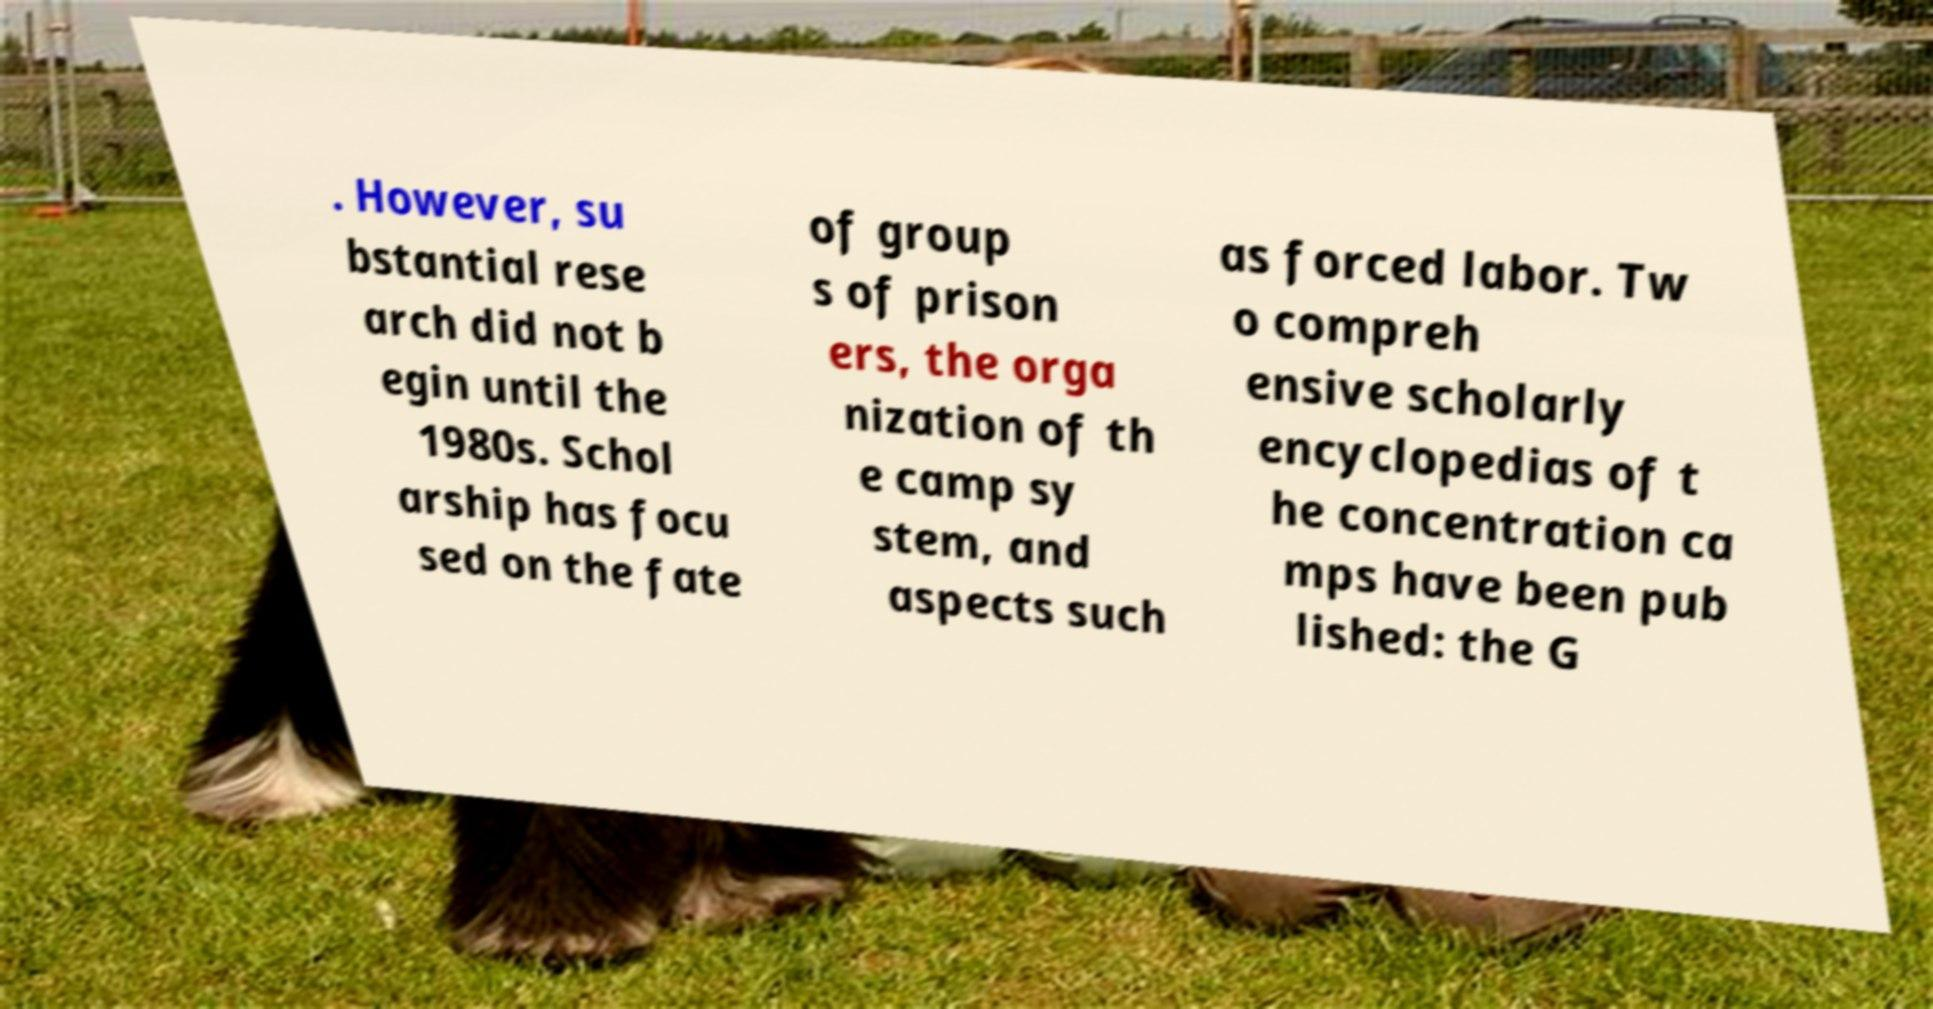For documentation purposes, I need the text within this image transcribed. Could you provide that? . However, su bstantial rese arch did not b egin until the 1980s. Schol arship has focu sed on the fate of group s of prison ers, the orga nization of th e camp sy stem, and aspects such as forced labor. Tw o compreh ensive scholarly encyclopedias of t he concentration ca mps have been pub lished: the G 